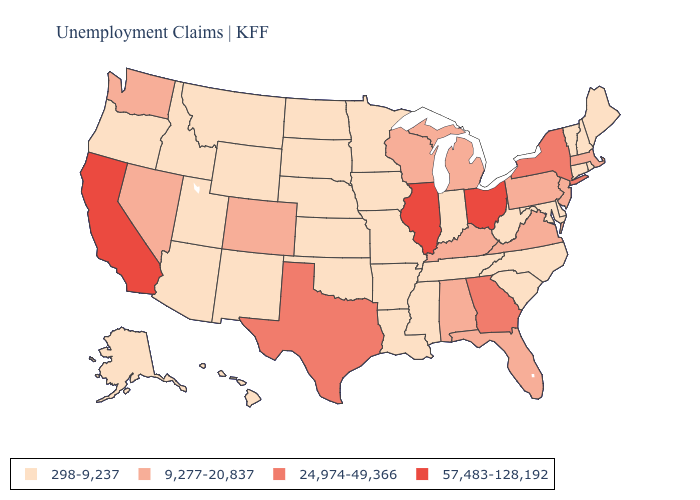Does Illinois have the highest value in the MidWest?
Be succinct. Yes. What is the highest value in the USA?
Keep it brief. 57,483-128,192. Name the states that have a value in the range 57,483-128,192?
Keep it brief. California, Illinois, Ohio. Does Iowa have a higher value than Oklahoma?
Quick response, please. No. What is the lowest value in the West?
Keep it brief. 298-9,237. Name the states that have a value in the range 9,277-20,837?
Keep it brief. Alabama, Colorado, Florida, Kentucky, Massachusetts, Michigan, Nevada, New Jersey, Pennsylvania, Virginia, Washington, Wisconsin. Does the first symbol in the legend represent the smallest category?
Give a very brief answer. Yes. What is the lowest value in the West?
Answer briefly. 298-9,237. Does Nevada have a higher value than Vermont?
Be succinct. Yes. What is the value of California?
Short answer required. 57,483-128,192. What is the value of Tennessee?
Quick response, please. 298-9,237. What is the highest value in the MidWest ?
Concise answer only. 57,483-128,192. What is the value of Oregon?
Give a very brief answer. 298-9,237. What is the highest value in the USA?
Answer briefly. 57,483-128,192. 